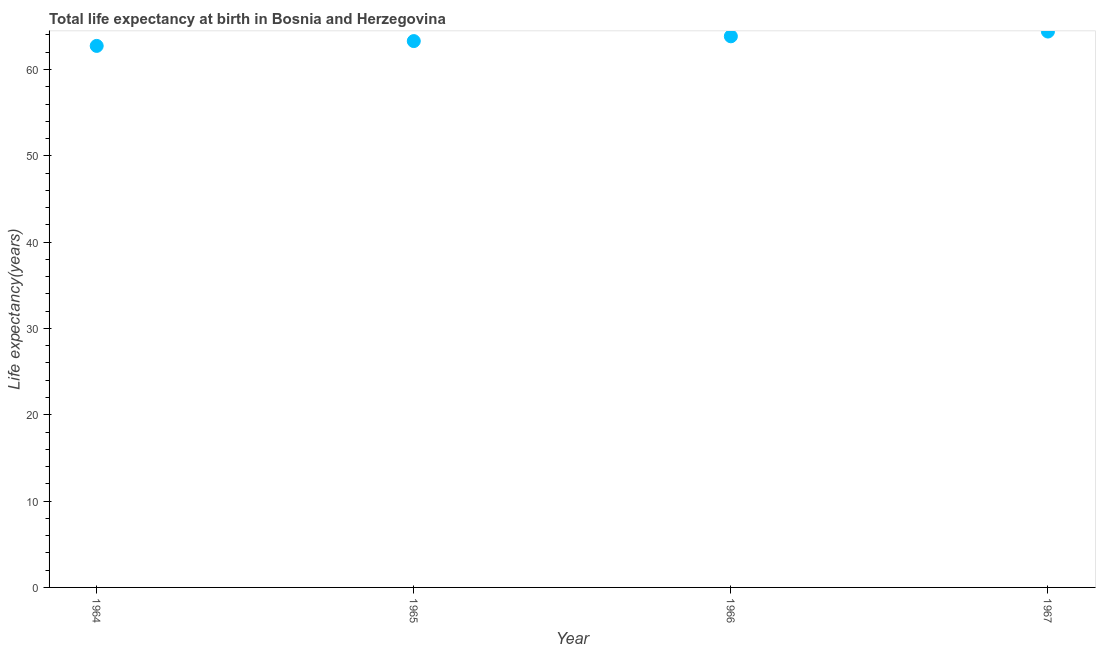What is the life expectancy at birth in 1967?
Provide a succinct answer. 64.4. Across all years, what is the maximum life expectancy at birth?
Ensure brevity in your answer.  64.4. Across all years, what is the minimum life expectancy at birth?
Your answer should be very brief. 62.73. In which year was the life expectancy at birth maximum?
Your response must be concise. 1967. In which year was the life expectancy at birth minimum?
Provide a short and direct response. 1964. What is the sum of the life expectancy at birth?
Ensure brevity in your answer.  254.27. What is the difference between the life expectancy at birth in 1965 and 1967?
Provide a short and direct response. -1.11. What is the average life expectancy at birth per year?
Ensure brevity in your answer.  63.57. What is the median life expectancy at birth?
Make the answer very short. 63.57. In how many years, is the life expectancy at birth greater than 2 years?
Offer a very short reply. 4. What is the ratio of the life expectancy at birth in 1966 to that in 1967?
Ensure brevity in your answer.  0.99. What is the difference between the highest and the second highest life expectancy at birth?
Your answer should be very brief. 0.55. Is the sum of the life expectancy at birth in 1965 and 1967 greater than the maximum life expectancy at birth across all years?
Provide a succinct answer. Yes. What is the difference between the highest and the lowest life expectancy at birth?
Your response must be concise. 1.66. In how many years, is the life expectancy at birth greater than the average life expectancy at birth taken over all years?
Your answer should be compact. 2. How many years are there in the graph?
Keep it short and to the point. 4. What is the difference between two consecutive major ticks on the Y-axis?
Offer a terse response. 10. Are the values on the major ticks of Y-axis written in scientific E-notation?
Make the answer very short. No. What is the title of the graph?
Your answer should be compact. Total life expectancy at birth in Bosnia and Herzegovina. What is the label or title of the Y-axis?
Offer a very short reply. Life expectancy(years). What is the Life expectancy(years) in 1964?
Offer a very short reply. 62.73. What is the Life expectancy(years) in 1965?
Your answer should be very brief. 63.29. What is the Life expectancy(years) in 1966?
Keep it short and to the point. 63.84. What is the Life expectancy(years) in 1967?
Give a very brief answer. 64.4. What is the difference between the Life expectancy(years) in 1964 and 1965?
Offer a terse response. -0.56. What is the difference between the Life expectancy(years) in 1964 and 1966?
Ensure brevity in your answer.  -1.11. What is the difference between the Life expectancy(years) in 1964 and 1967?
Give a very brief answer. -1.66. What is the difference between the Life expectancy(years) in 1965 and 1966?
Offer a very short reply. -0.55. What is the difference between the Life expectancy(years) in 1965 and 1967?
Your answer should be very brief. -1.11. What is the difference between the Life expectancy(years) in 1966 and 1967?
Ensure brevity in your answer.  -0.55. What is the ratio of the Life expectancy(years) in 1964 to that in 1965?
Ensure brevity in your answer.  0.99. What is the ratio of the Life expectancy(years) in 1965 to that in 1967?
Offer a terse response. 0.98. What is the ratio of the Life expectancy(years) in 1966 to that in 1967?
Make the answer very short. 0.99. 